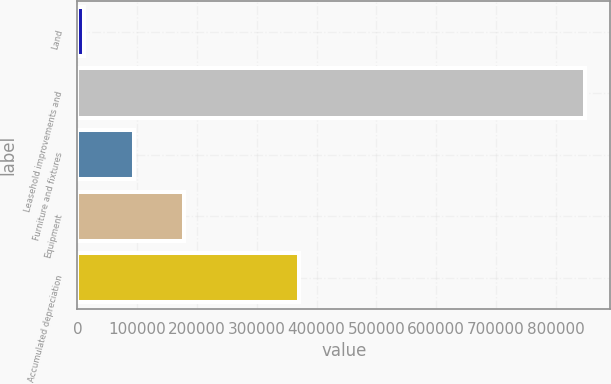<chart> <loc_0><loc_0><loc_500><loc_500><bar_chart><fcel>Land<fcel>Leasehold improvements and<fcel>Furniture and fixtures<fcel>Equipment<fcel>Accumulated depreciation<nl><fcel>11062<fcel>849102<fcel>94866<fcel>178670<fcel>370169<nl></chart> 